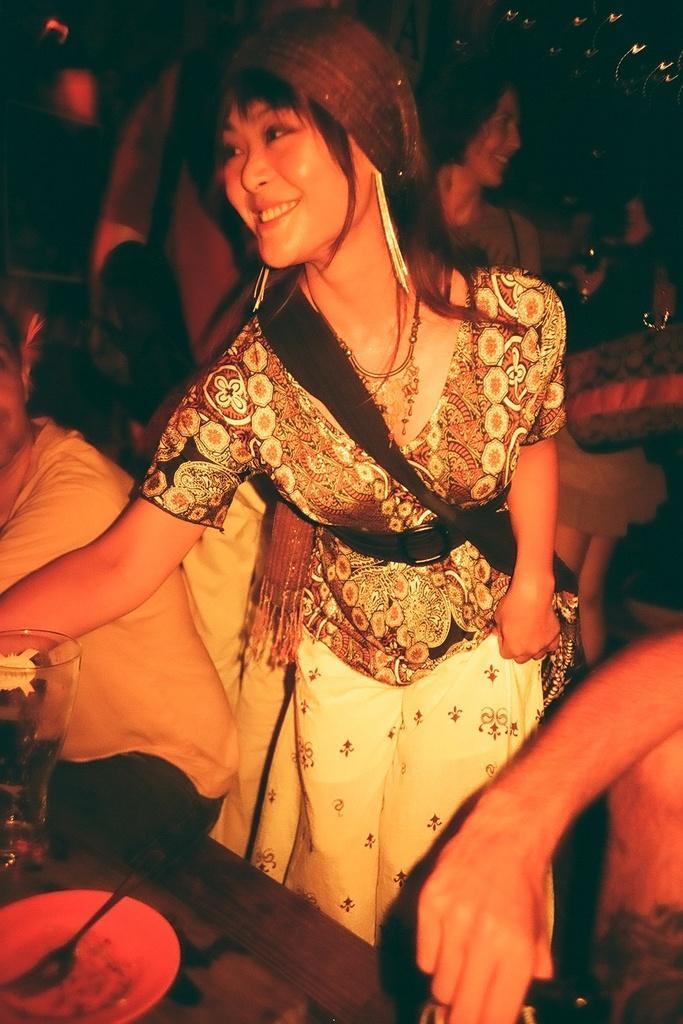In one or two sentences, can you explain what this image depicts? In the foreground of this image, on the bottom, there is a hand of a person. In the middle, there is a woman standing and having smile on her face. In front of her, there is table on which platter, fork and glass are placed. In the background, there are persons in the dark. On the left, there is a man sitting on the bench. 